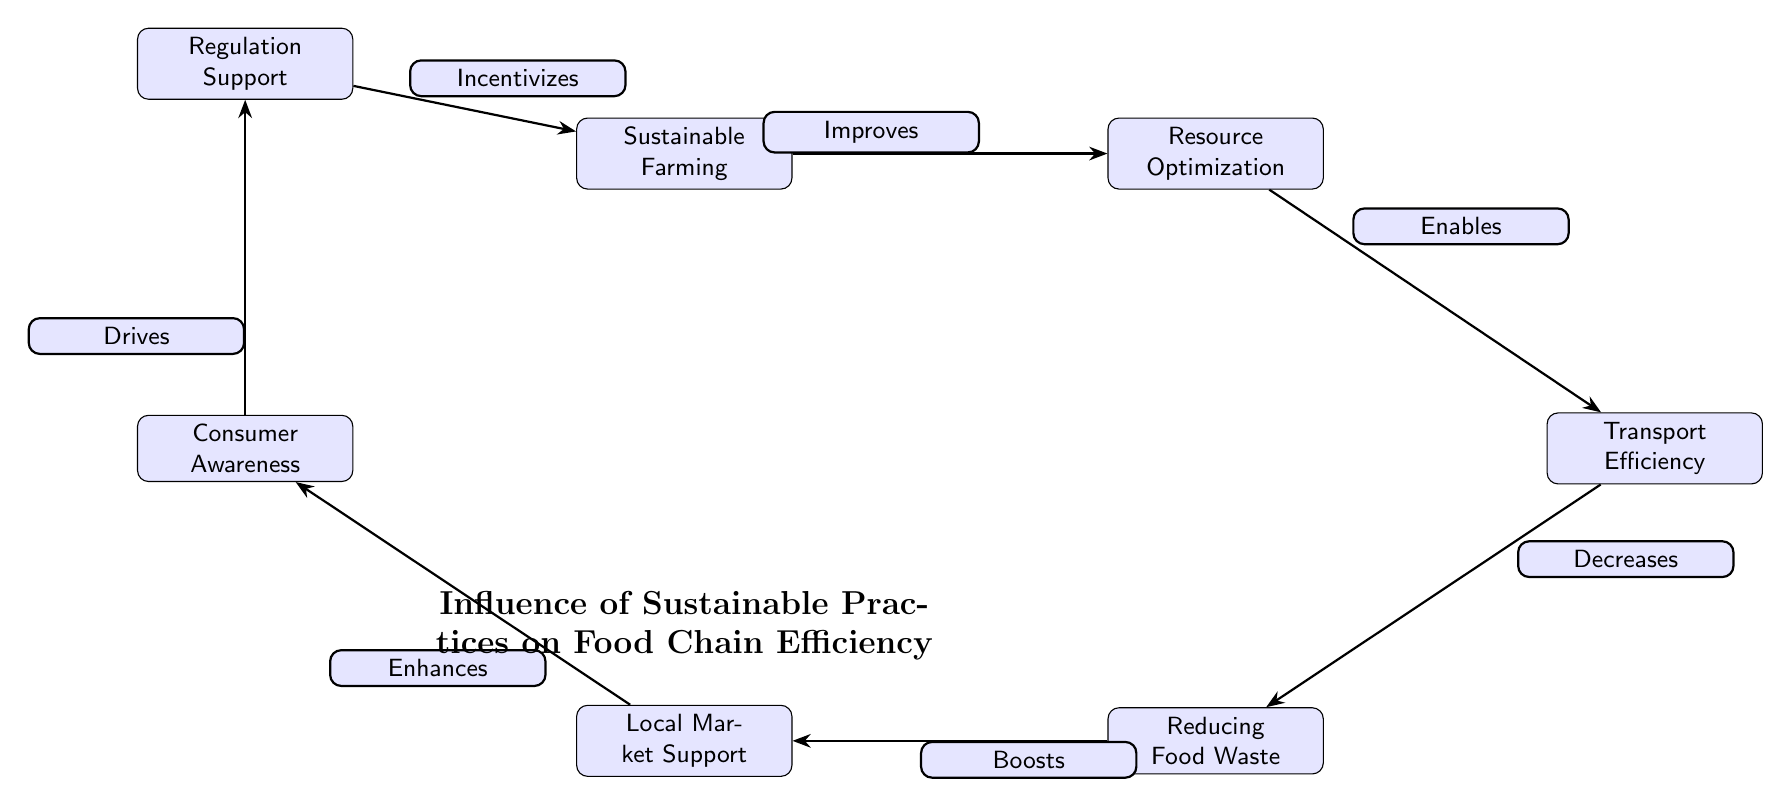What is the first node in the diagram? The diagram starts with "Sustainable Farming" as the first node, which represents the beginning of the influence flow in the food chain.
Answer: Sustainable Farming How many nodes are present in the diagram? Counting each unique item in the diagram, we find there are a total of seven nodes, including "Sustainable Farming," "Resource Optimization," "Transport Efficiency," "Reducing Food Waste," "Local Market Support," "Consumer Awareness," and "Regulation Support."
Answer: 7 What relationship does "Resource Optimization" have with "Transport Efficiency"? According to the diagram, "Resource Optimization" edges out towards "Transport Efficiency," with the label "Enables" indicating the type of relationship, showing that resource optimization allows for more efficient transport.
Answer: Enables Which node is directly influenced by "Reducing Food Waste"? The diagram shows that "Reducing Food Waste" has a direct influence on the node "Local Market Support," represented by the edge labeled "Boosts." This indicates that reducing food waste positively affects local market activities.
Answer: Local Market Support What is the last node in the flow of the diagram? The last node, which concludes the flow of relationships in the diagram, is "Sustainable Farming," which not only starts the flow but also influences the beginning by returning in the circular structure indicated.
Answer: Sustainable Farming Explain the connection between "Consumer Awareness" and "Regulation Support." The diagram indicates that "Consumer Awareness" drives "Regulation Support," showing that increased awareness among consumers propels support for regulations that may enhance sustainability in the food chain. This is also significant as it shows an interaction between consumer behavior and legislative support.
Answer: Drives How does "Transport Efficiency" relate to "Reducing Food Waste"? According to the diagram, "Transport Efficiency" decreases "Reducing Food Waste," suggesting that improvements in transport efficiency lead to less food waste, likely due to better handling, storage, and less spoilage during transportation.
Answer: Decreases What are the potential benefits of "Sustainable Farming"? The diagram suggests that "Sustainable Farming" improves "Resource Optimization," which can lead to various benefits throughout the food chain, indicating its foundational importance to the overall system.
Answer: Improves What type of diagram is represented here? The diagram illustrates a food chain, specifically highlighting the influence of sustainable practices on food chain efficiency, showing a flow of interactions between different components.
Answer: Food chain 